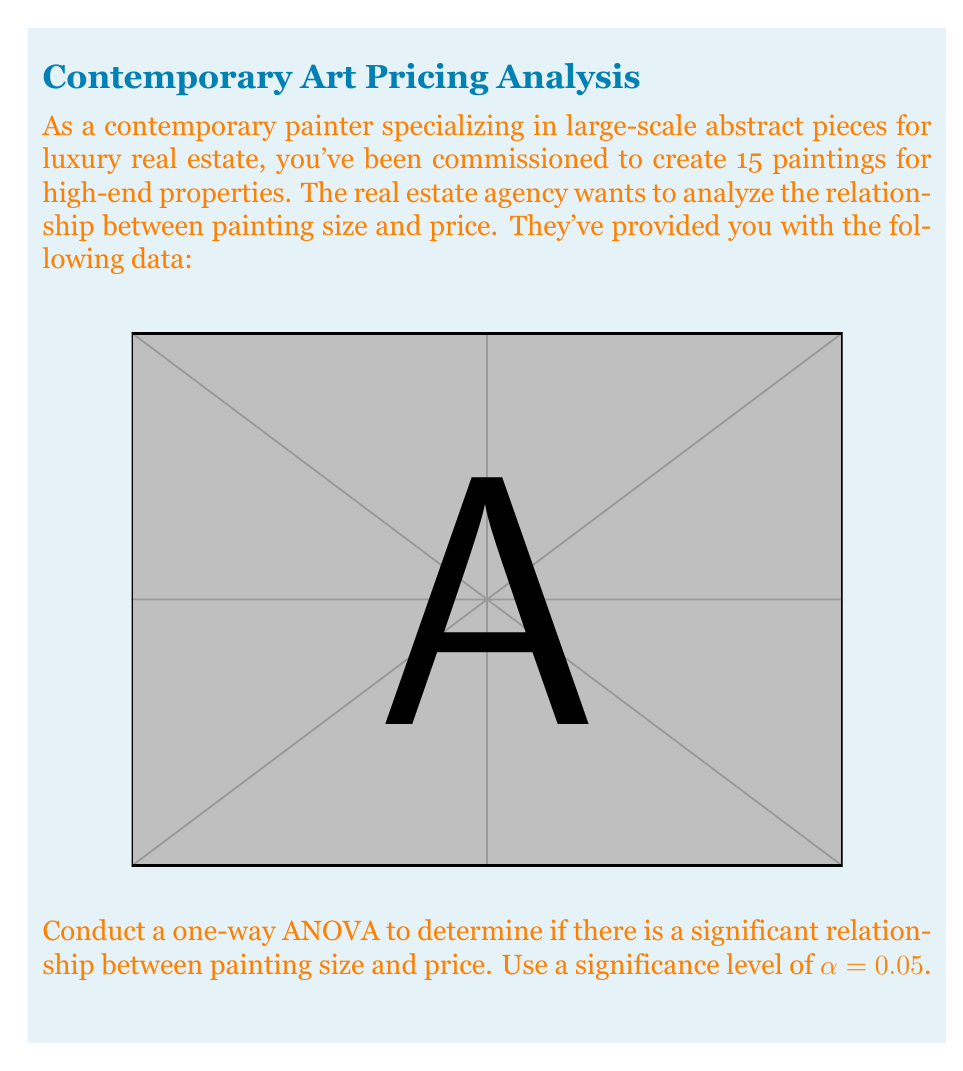What is the answer to this math problem? To conduct a one-way ANOVA, we'll follow these steps:

1. Calculate the total sum of squares (SST):
   $$SST = \sum_{i=1}^{n} (y_i - \bar{y})^2$$
   where $y_i$ are the individual prices and $\bar{y}$ is the mean price.

2. Calculate the regression sum of squares (SSR):
   $$SSR = \sum_{i=1}^{n} (\hat{y}_i - \bar{y})^2$$
   where $\hat{y}_i$ are the predicted prices based on the regression line.

3. Calculate the error sum of squares (SSE):
   $$SSE = SST - SSR$$

4. Calculate the degrees of freedom:
   $df_{between} = 1$ (for simple linear regression)
   $df_{within} = n - 2 = 13$ (where n is the number of data points)
   $df_{total} = n - 1 = 14$

5. Calculate the mean squares:
   $$MS_{between} = \frac{SSR}{df_{between}}$$
   $$MS_{within} = \frac{SSE}{df_{within}}$$

6. Calculate the F-statistic:
   $$F = \frac{MS_{between}}{MS_{within}}$$

7. Compare the F-statistic to the critical F-value:
   $F_{critical} = F_{0.05,1,13}$ (from F-distribution table)

Using statistical software or a calculator, we get:
SST = 474,750,000
SSR = 468,017,647
SSE = 6,732,353

$MS_{between} = 468,017,647$
$MS_{within} = 517,873.31$

$F = \frac{468,017,647}{517,873.31} = 903.73$

$F_{critical} = 4.67$ (from F-distribution table)

Since $F > F_{critical}$, we reject the null hypothesis.
Answer: There is a significant relationship between painting size and price (F = 903.73, p < 0.05). 